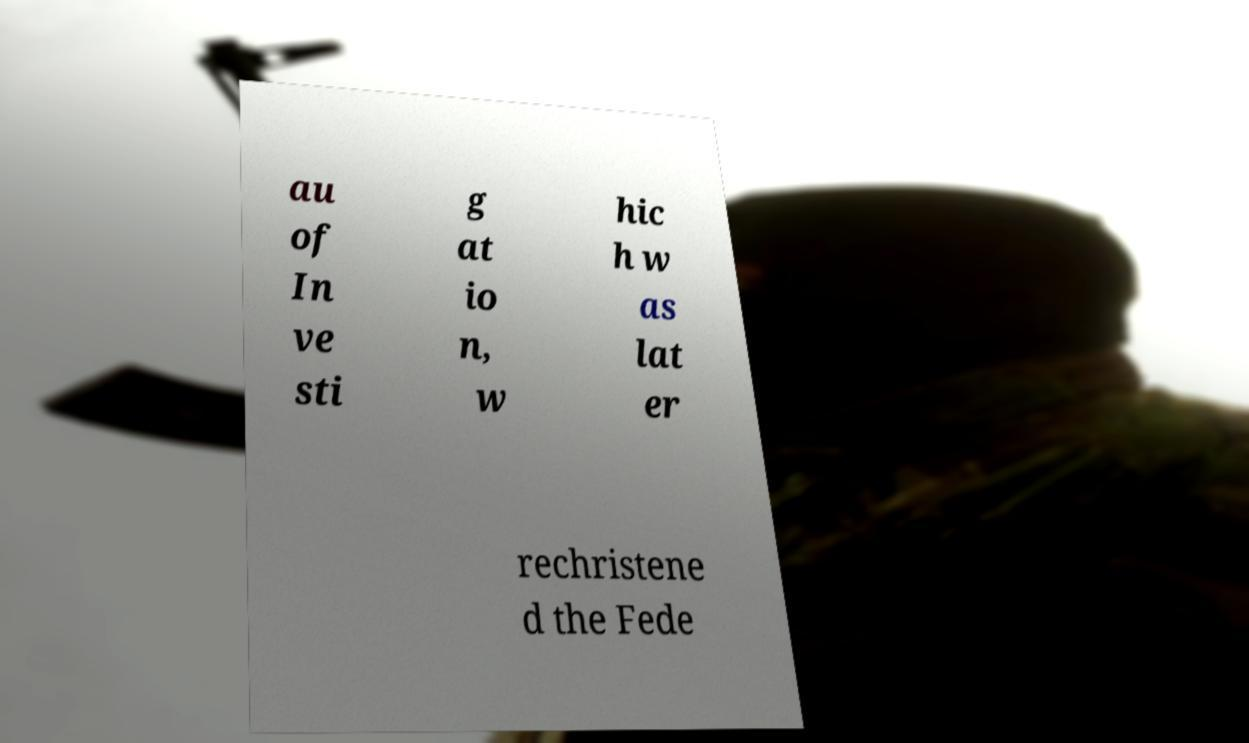What messages or text are displayed in this image? I need them in a readable, typed format. au of In ve sti g at io n, w hic h w as lat er rechristene d the Fede 